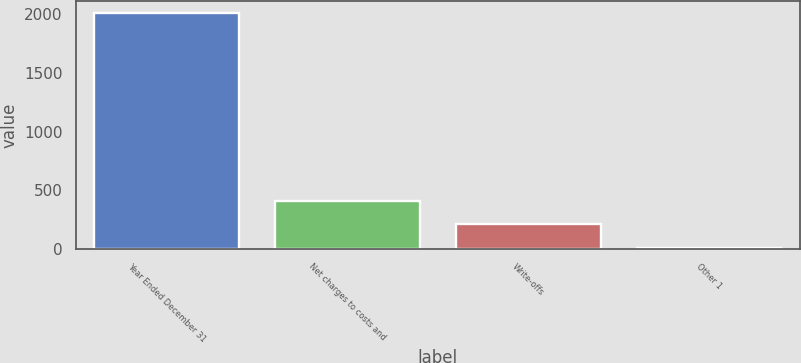<chart> <loc_0><loc_0><loc_500><loc_500><bar_chart><fcel>Year Ended December 31<fcel>Net charges to costs and<fcel>Write-offs<fcel>Other 1<nl><fcel>2010<fcel>410<fcel>210<fcel>10<nl></chart> 